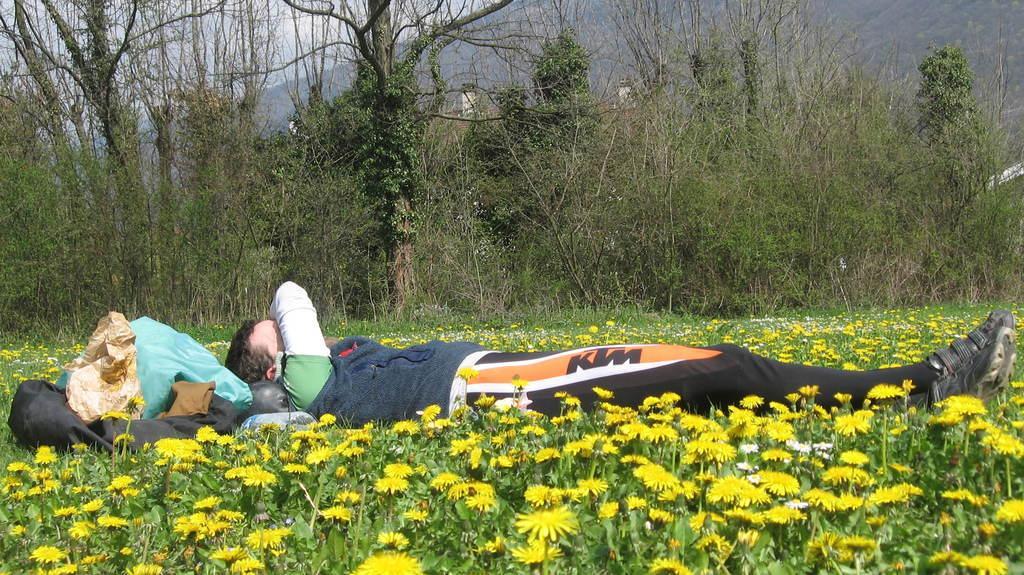Please provide a concise description of this image. In this picture I can see trees and few plants with flowers and I can see a man lying and few clothes on the left side. I can see a hill and a cloudy sky in the back. 